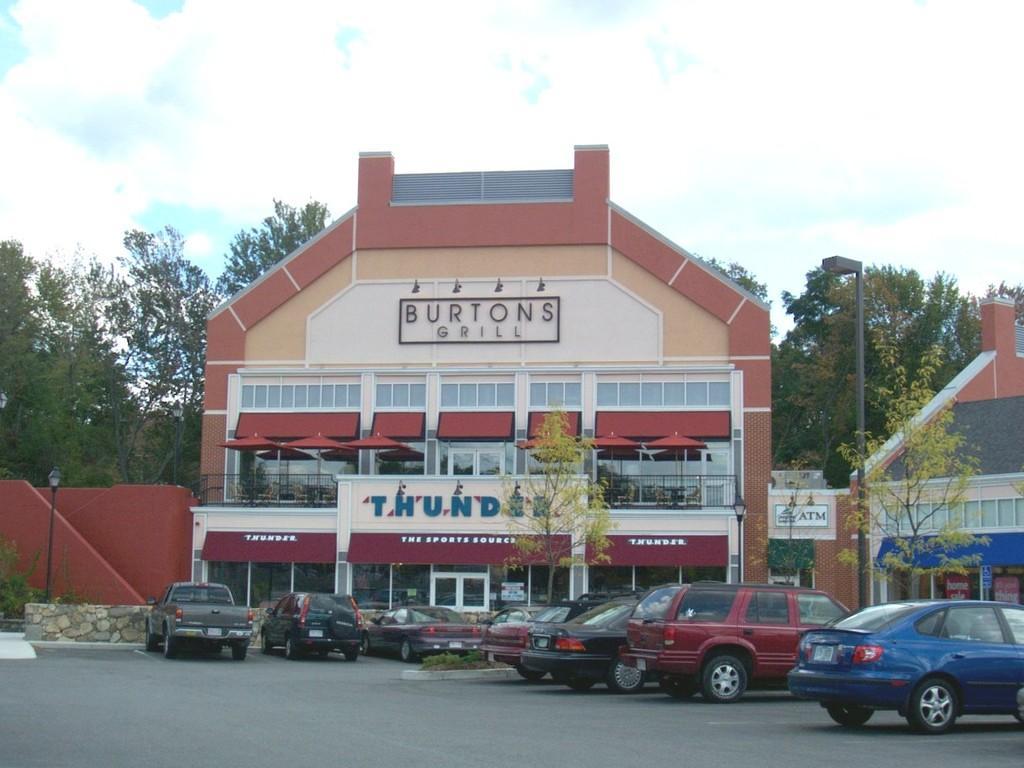Can you describe this image briefly? In the center of the image there is a building and tree. At the bottom of the image we can see vehicles on the road. In the background we can see trees, sky and clouds. 